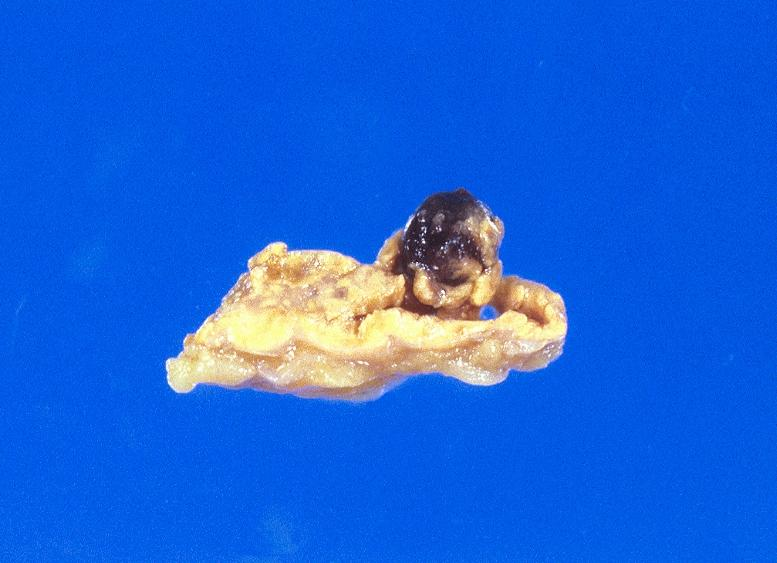what is present?
Answer the question using a single word or phrase. Soft tissue 